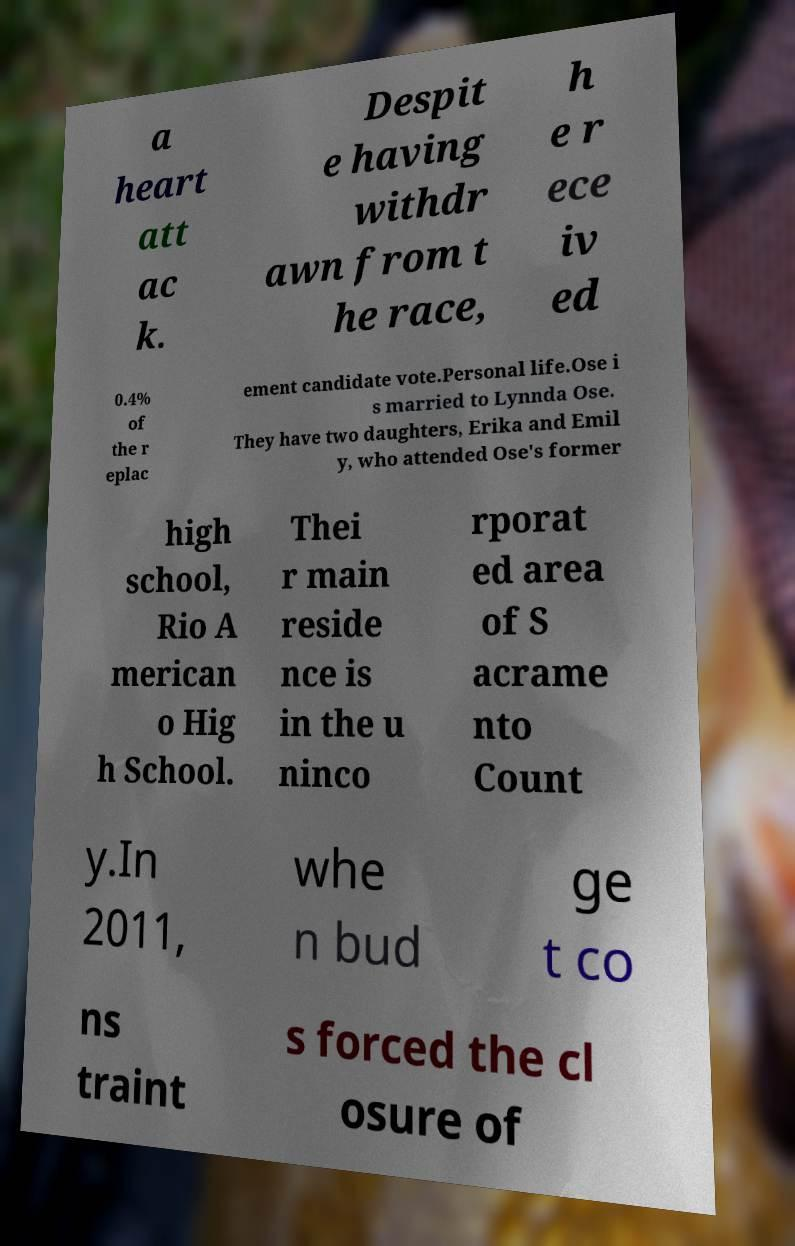There's text embedded in this image that I need extracted. Can you transcribe it verbatim? a heart att ac k. Despit e having withdr awn from t he race, h e r ece iv ed 0.4% of the r eplac ement candidate vote.Personal life.Ose i s married to Lynnda Ose. They have two daughters, Erika and Emil y, who attended Ose's former high school, Rio A merican o Hig h School. Thei r main reside nce is in the u ninco rporat ed area of S acrame nto Count y.In 2011, whe n bud ge t co ns traint s forced the cl osure of 